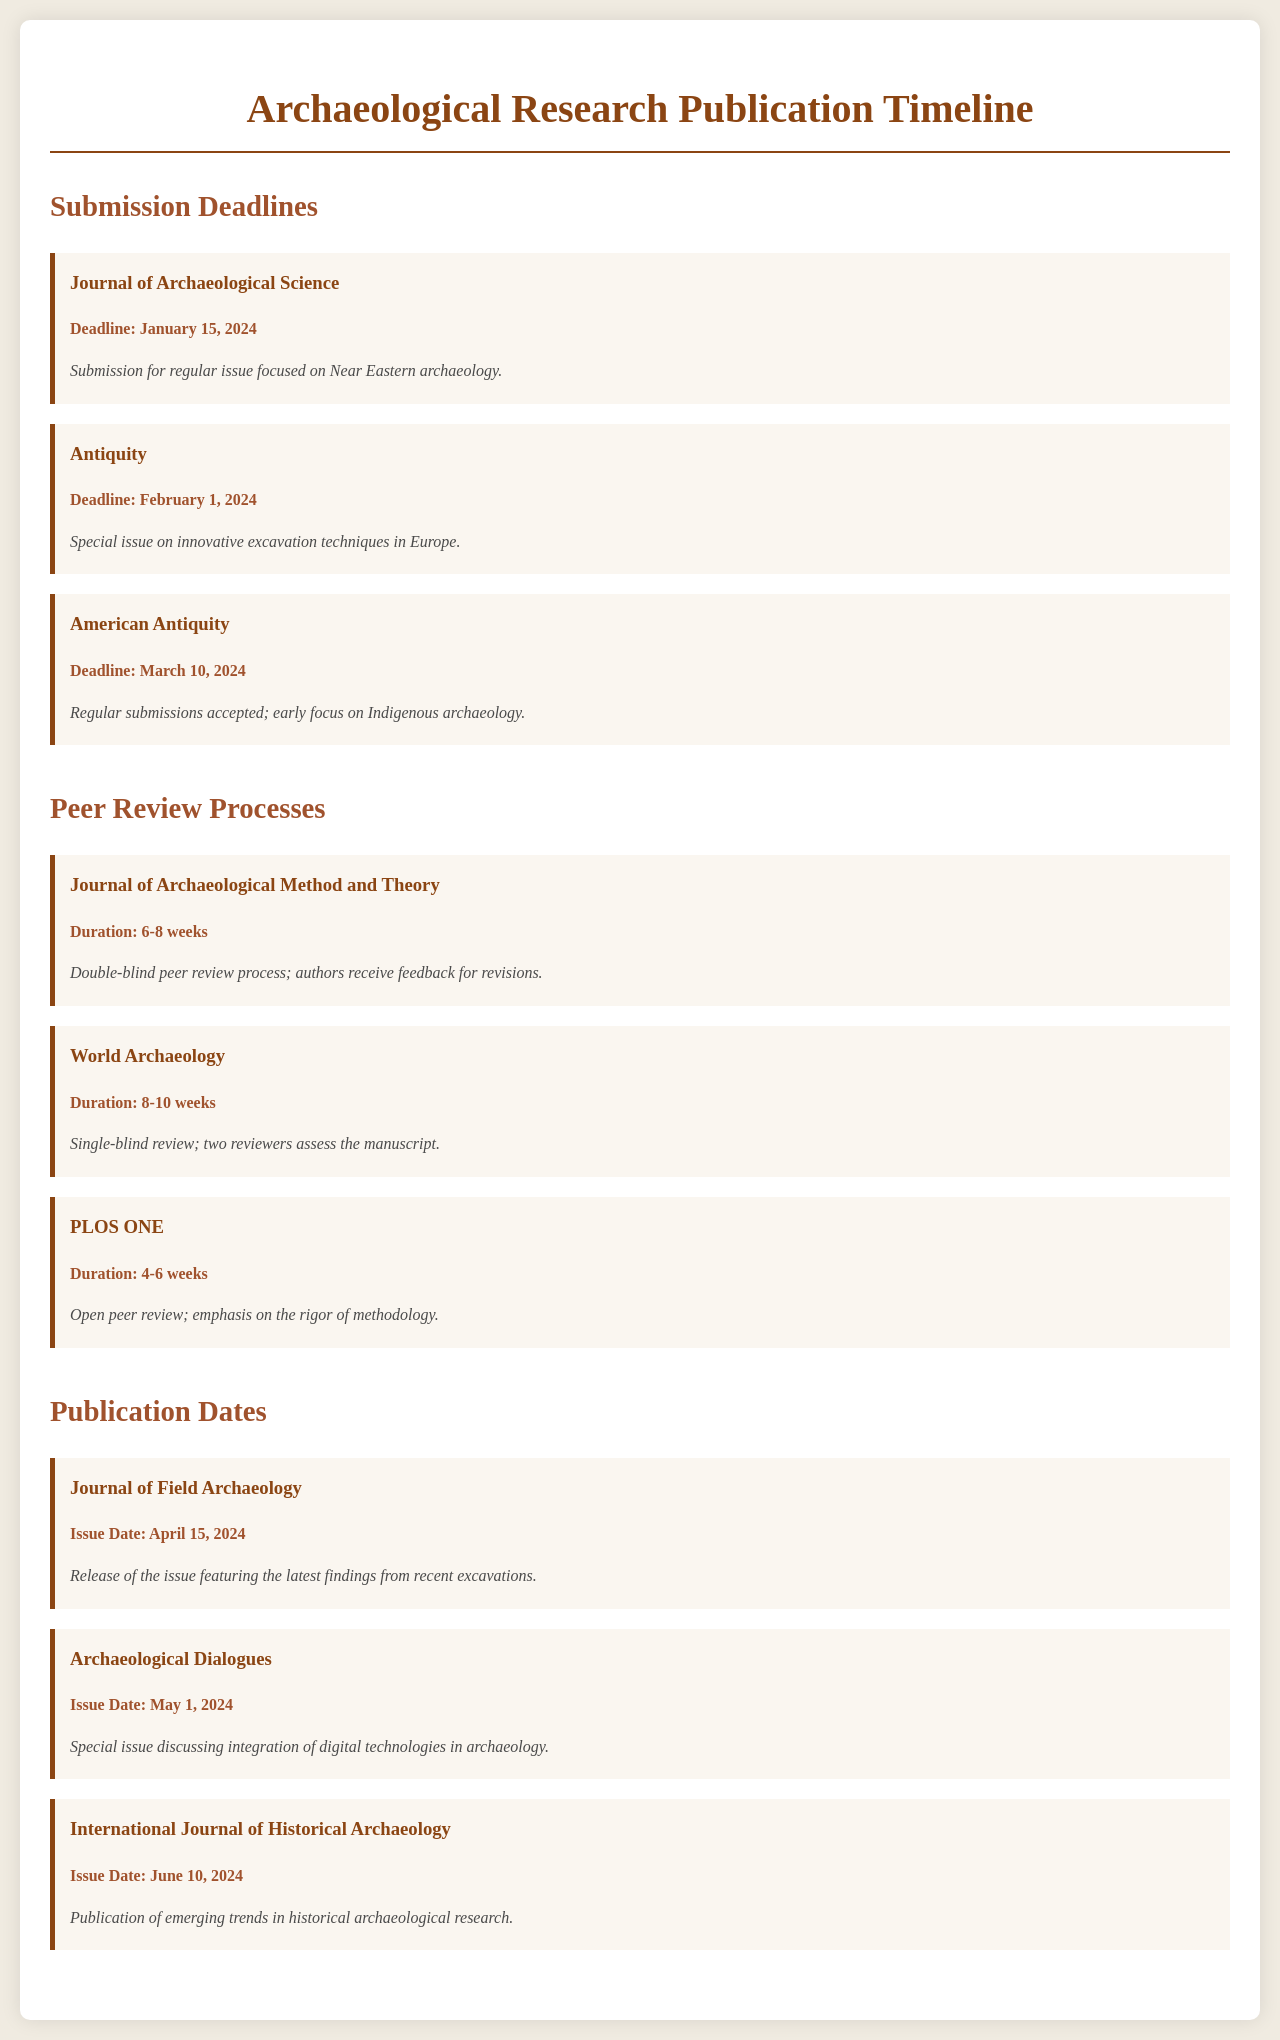what is the submission deadline for the Journal of Archaeological Science? The submission deadline is specified in the document under the Submission Deadlines section for the Journal of Archaeological Science.
Answer: January 15, 2024 what is the peer review duration for PLOS ONE? The peer review duration is listed in the document under the Peer Review Processes section for PLOS ONE.
Answer: 4-6 weeks when is the issue date for Archaeological Dialogues? The issue date for Archaeological Dialogues is stated in the Publication Dates section.
Answer: May 1, 2024 which journal has a submission deadline focused on Indigenous archaeology? This information can be retrieved from the Submission Deadlines section detailing the journals and their specific focuses.
Answer: American Antiquity how long does the peer review process take for World Archaeology? The duration for the peer review process is mentioned in the Peer Review Processes section for World Archaeology.
Answer: 8-10 weeks what special issue is submitted to Antiquity? The special issue topic is provided in the description of the Antiquity entry in the Submission Deadlines section.
Answer: innovative excavation techniques in Europe which journal features findings from recent excavations in its April issue? This can be answered by reviewing the information provided in the Publication Dates section.
Answer: Journal of Field Archaeology how many weeks is the peer review process for the Journal of Archaeological Method and Theory? The peer review duration can be found in the Peer Review Processes section specifically for this journal.
Answer: 6-8 weeks what is the focus of the special issue for the Journal of Field Archaeology? This information can be deduced from the description of the journal's publication in the document.
Answer: latest findings from recent excavations 